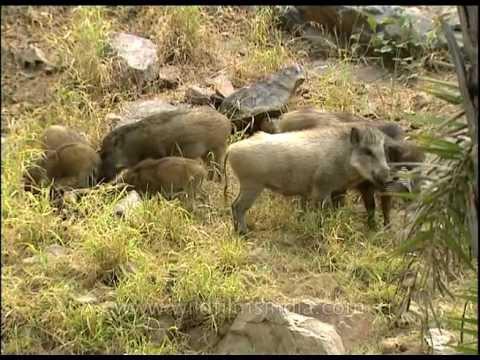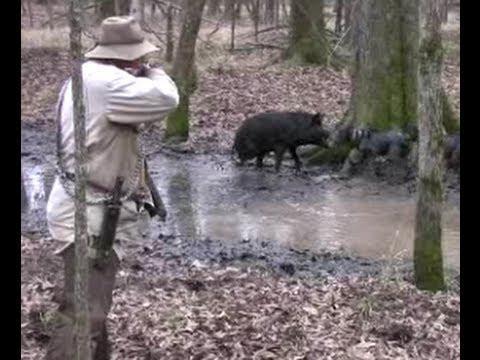The first image is the image on the left, the second image is the image on the right. Examine the images to the left and right. Is the description "Two hunters are posing with their kill in the image on the right." accurate? Answer yes or no. No. The first image is the image on the left, the second image is the image on the right. Examine the images to the left and right. Is the description "In total, two dead hogs are shown." accurate? Answer yes or no. No. 